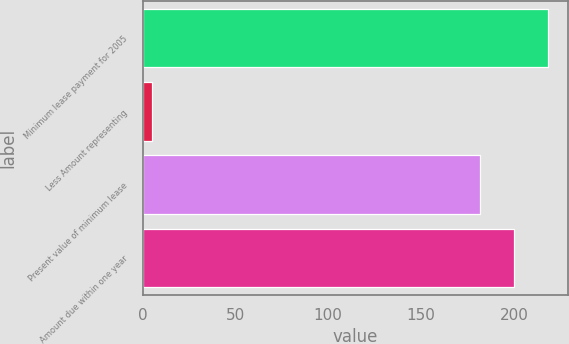Convert chart. <chart><loc_0><loc_0><loc_500><loc_500><bar_chart><fcel>Minimum lease payment for 2005<fcel>Less Amount representing<fcel>Present value of minimum lease<fcel>Amount due within one year<nl><fcel>218.4<fcel>5<fcel>182<fcel>200.2<nl></chart> 